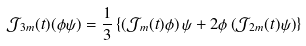Convert formula to latex. <formula><loc_0><loc_0><loc_500><loc_500>\mathcal { J } _ { 3 m } ( t ) ( \phi \psi ) = \frac { 1 } { 3 } \left \{ \left ( \mathcal { J } _ { m } ( t ) \phi \right ) \psi + 2 \phi \left ( \mathcal { J } _ { 2 m } ( t ) \psi \right ) \right \}</formula> 